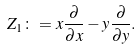<formula> <loc_0><loc_0><loc_500><loc_500>Z _ { 1 } \colon = x \frac { \partial } { \partial x } - y \frac { \partial } { \partial y } .</formula> 